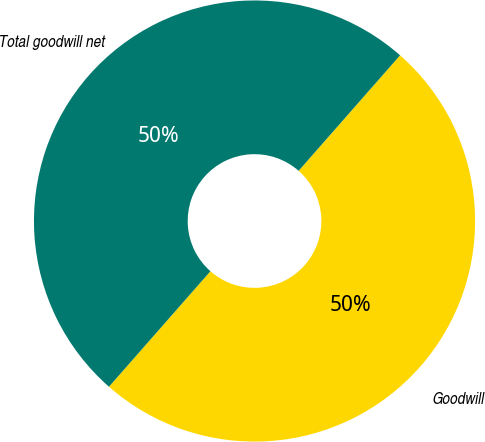Convert chart. <chart><loc_0><loc_0><loc_500><loc_500><pie_chart><fcel>Goodwill<fcel>Total goodwill net<nl><fcel>50.0%<fcel>50.0%<nl></chart> 